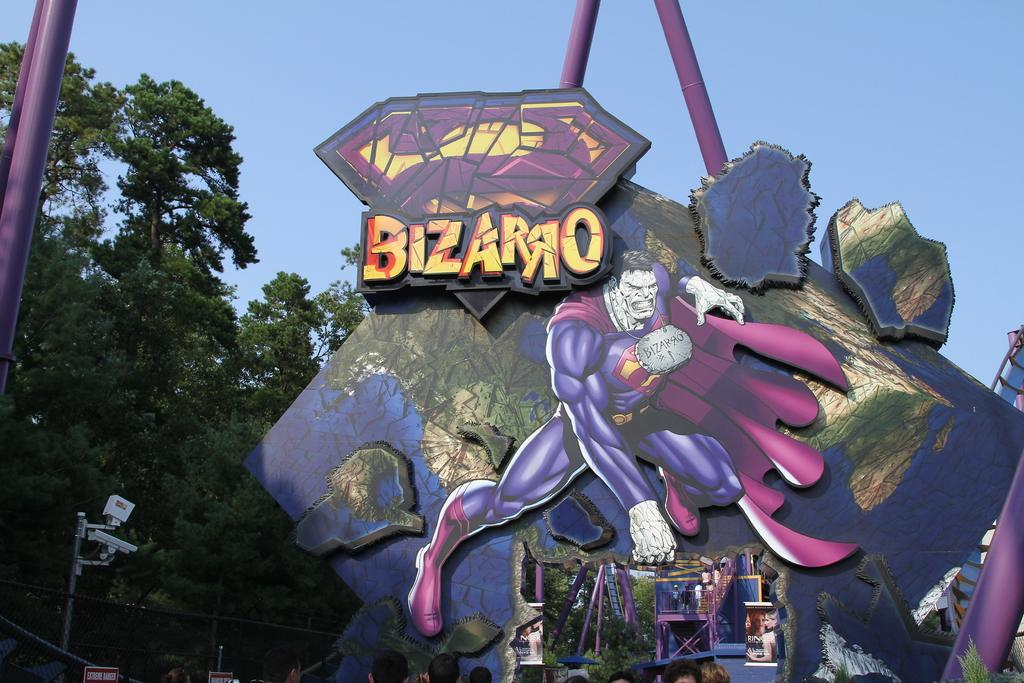What is the main subject of the image? The main subject of the image is a roller coaster. What are the people in the image doing? The people in the image are standing on the roller coaster. What can be seen in front of the roller coaster? There are trees in front of the roller coaster. What devices are visible in the image? There are cameras visible in the image. What type of vase can be seen on the roller coaster in the image? There is no vase present on the roller coaster in the image. What sound does the roller coaster make as it moves in the image? The image is static, so no sound can be heard or depicted. 